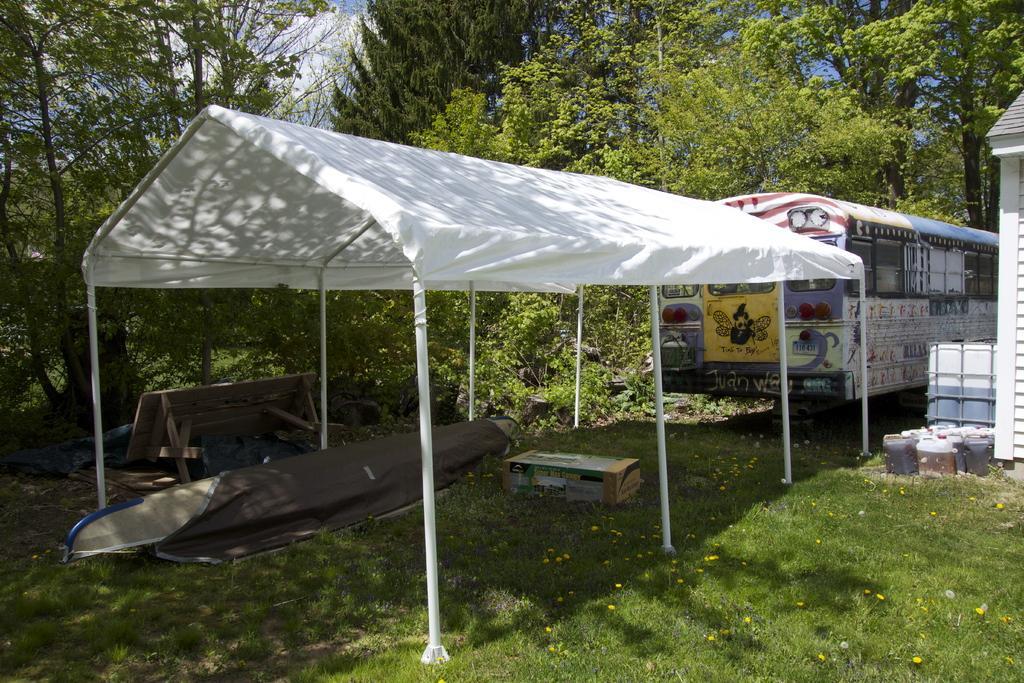How would you summarize this image in a sentence or two? At the bottom of the picture, we see the grass and the flowers in yellow color. We see a grey color sheet and a carton box is placed under the white tent. Beside that, we see a wooden bench or a table. On the right side, we see a building in white color. Beside that, we see the plastic cans or the containers. Beside that, we see a vehicle in yellow, blue and white color. There are trees in the background. This picture might be clicked in the garden. 